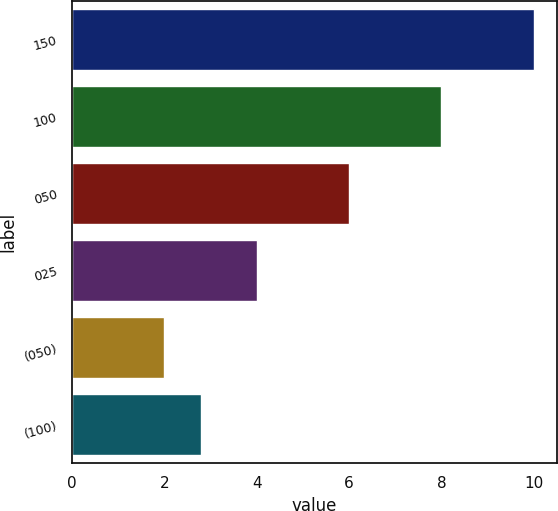<chart> <loc_0><loc_0><loc_500><loc_500><bar_chart><fcel>150<fcel>100<fcel>050<fcel>025<fcel>(050)<fcel>(100)<nl><fcel>10<fcel>8<fcel>6<fcel>4<fcel>2<fcel>2.8<nl></chart> 